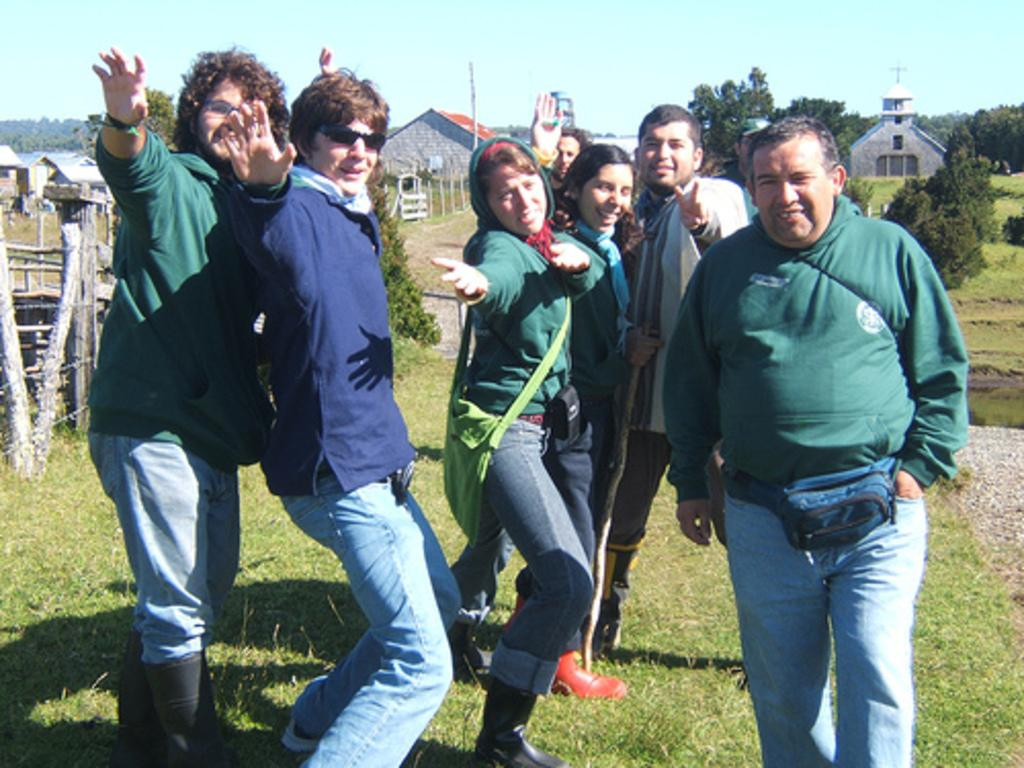Who or what can be seen in the image? There are people in the image. What can be seen in the distance behind the people? There are trees and houses in the background of the image. What is the color of the sky in the image? The sky is blue in color. What type of sidewalk can be seen in the image? There is no sidewalk present in the image. How are the people in the image sorting the nation? The image does not depict any sorting or nation-related activities. 